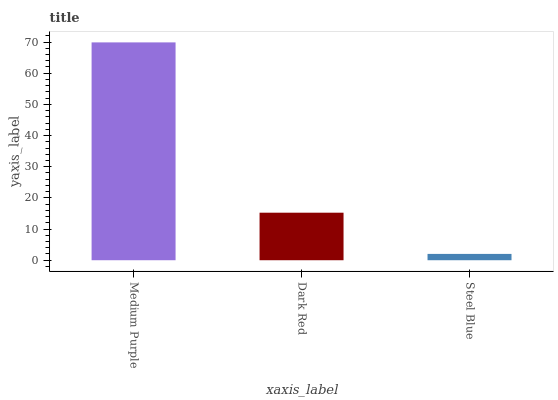Is Steel Blue the minimum?
Answer yes or no. Yes. Is Medium Purple the maximum?
Answer yes or no. Yes. Is Dark Red the minimum?
Answer yes or no. No. Is Dark Red the maximum?
Answer yes or no. No. Is Medium Purple greater than Dark Red?
Answer yes or no. Yes. Is Dark Red less than Medium Purple?
Answer yes or no. Yes. Is Dark Red greater than Medium Purple?
Answer yes or no. No. Is Medium Purple less than Dark Red?
Answer yes or no. No. Is Dark Red the high median?
Answer yes or no. Yes. Is Dark Red the low median?
Answer yes or no. Yes. Is Steel Blue the high median?
Answer yes or no. No. Is Medium Purple the low median?
Answer yes or no. No. 